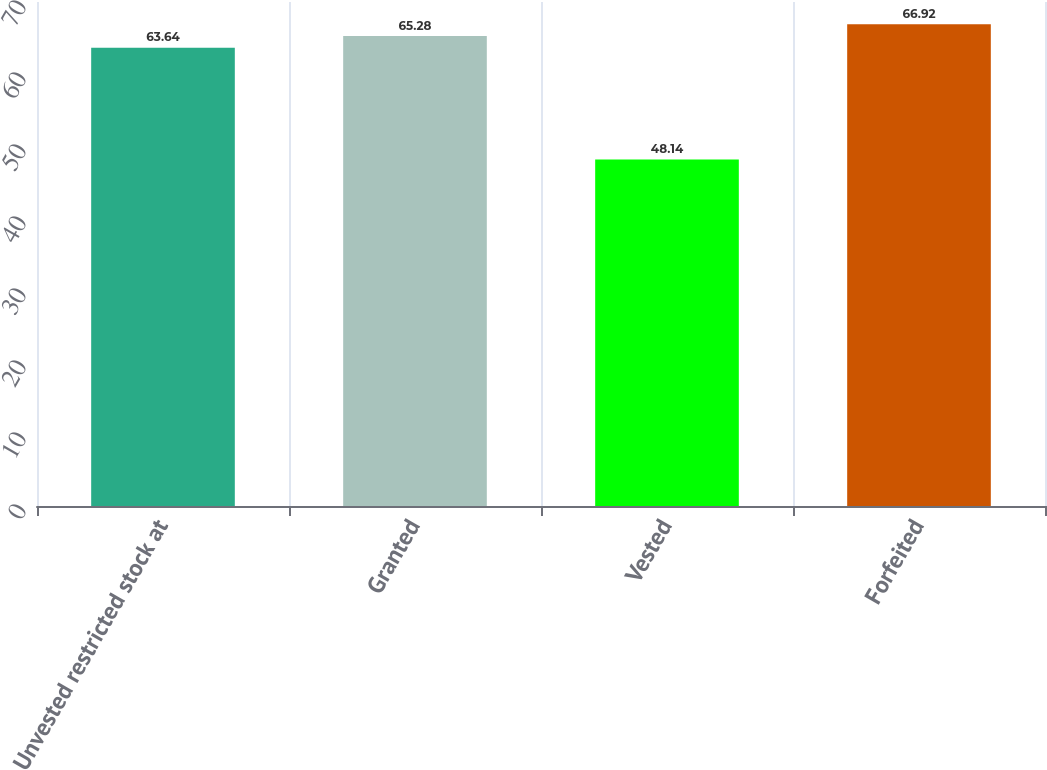<chart> <loc_0><loc_0><loc_500><loc_500><bar_chart><fcel>Unvested restricted stock at<fcel>Granted<fcel>Vested<fcel>Forfeited<nl><fcel>63.64<fcel>65.28<fcel>48.14<fcel>66.92<nl></chart> 